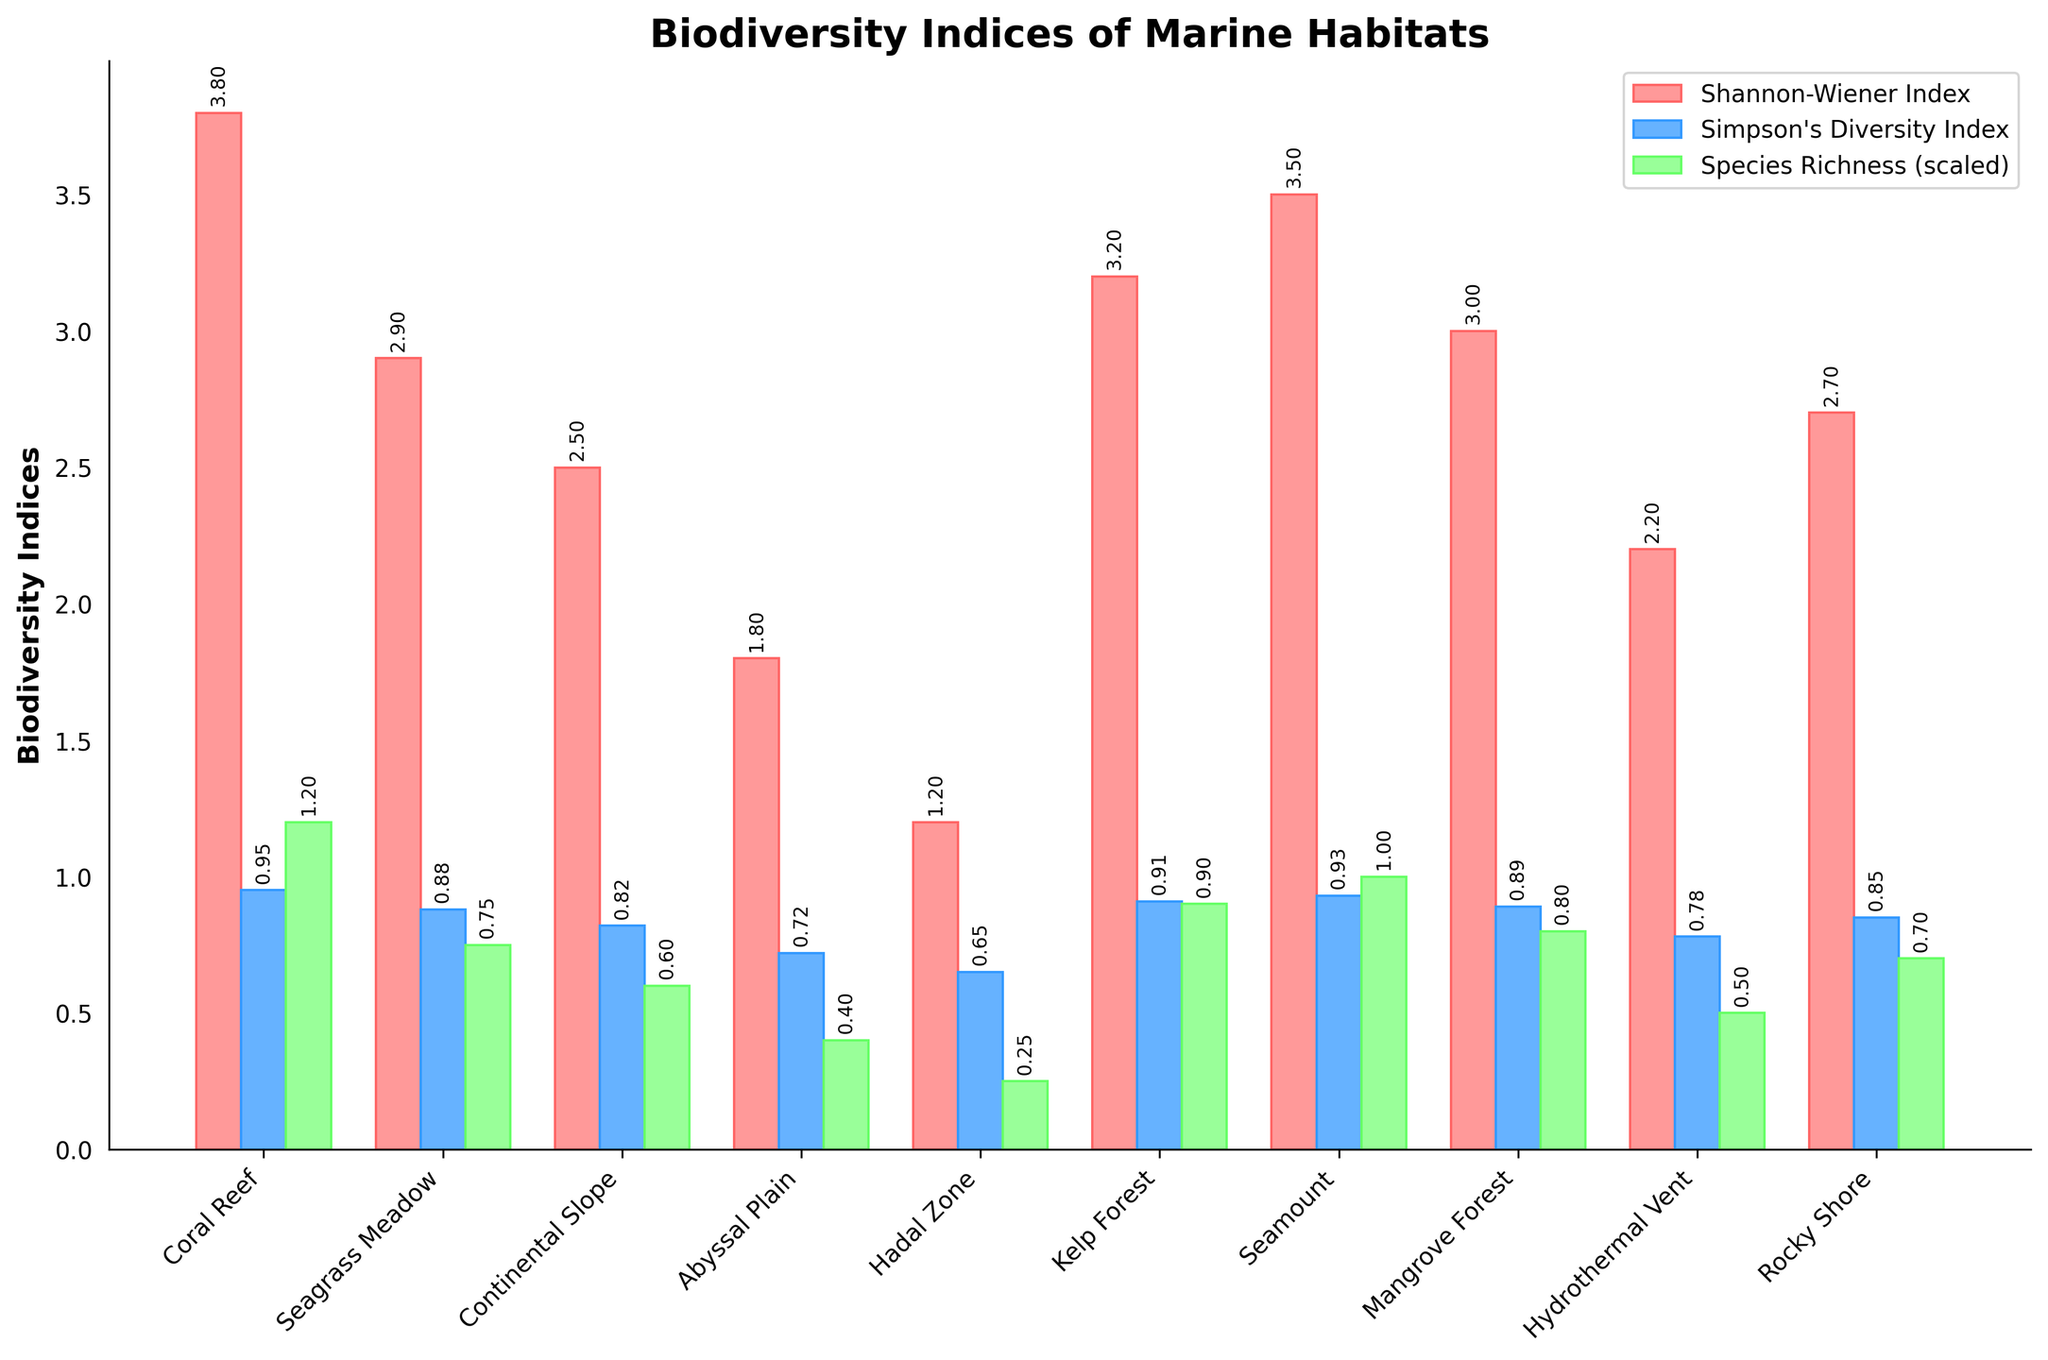Which habitat has the highest Shannon-Wiener Index? The chart indicates that the habitat with the highest Shannon-Wiener Index is represented by the bar with the greatest height in the red series.
Answer: Coral Reef What is the difference in Shannon-Wiener Index between Coral Reef and Abyssal Plain? Coral Reef has a Shannon-Wiener Index of 3.8, and Abyssal Plain has a value of 1.8. The difference is 3.8 - 1.8.
Answer: 2.0 Which habitat has a higher Simpson's Diversity Index: Seagrass Meadow or Rocky Shore? By comparing the blue bars representing Simpson's Diversity Index for both habitats, we see that Seagrass Meadow has a value of 0.88, and Rocky Shore has 0.85. Seagrass Meadow is higher.
Answer: Seagrass Meadow How many habitats have a Species Richness (scaled) higher than 0.75? Species Richness is scaled by 100. Thus, we need to check how many green bars exceed the height of 0.75. Those habitats are Coral Reef (1.2) and Kelp Forest (0.9).
Answer: 2 What is the average Shannon-Wiener Index for habitats in the 0-200m depth range? The habitats within the 0-200m range are Coral Reef (3.8), Seagrass Meadow (2.9), Kelp Forest (3.2), Mangrove Forest (3.0), and Rocky Shore (2.7). The average is (3.8 + 2.9 + 3.2 + 3.0 + 2.7)/5.
Answer: 3.12 Which habitat has the lowest Simpson's Diversity Index, and what is its value? The lowest Simpson's Diversity Index is represented by the shortest blue bar, which corresponds to the Hadal Zone with a value of 0.65.
Answer: Hadal Zone, 0.65 Compare Species Richness between Continental Slope and Seamount. Which one is higher and by how much? Continental Slope has a Species Richness of 60, and Seamount has 100. The difference is 100 - 60.
Answer: Seamount, 40 If you sum the Species Richness (scaled) for Coral Reef, Kelp Forest, and Hydrothermal Vent, what is the total value? Coral Reef has 1.2, Kelp Forest has 0.9, and Hydrothermal Vent has 0.5 in scaled values. The sum is 1.2 + 0.9 + 0.5.
Answer: 2.6 What is the median Simpson's Diversity Index? The Simpson's Diversity Index values are: 0.95, 0.88, 0.82, 0.72, 0.65, 0.91, 0.93, 0.89, 0.78, 0.85. Sorting: 0.65, 0.72, 0.78, 0.82, 0.85, 0.88, 0.89, 0.91, 0.93, 0.95. The median is (0.85 + 0.88)/2.
Answer: 0.865 How does the Shannon-Wiener Index of a Seamount compare to a Hydrothermal Vent? The Shannon-Wiener Index of a Seamount is 3.5, much higher than Hydrothermal Vent's 2.2.
Answer: Seamount is higher by 1.3 